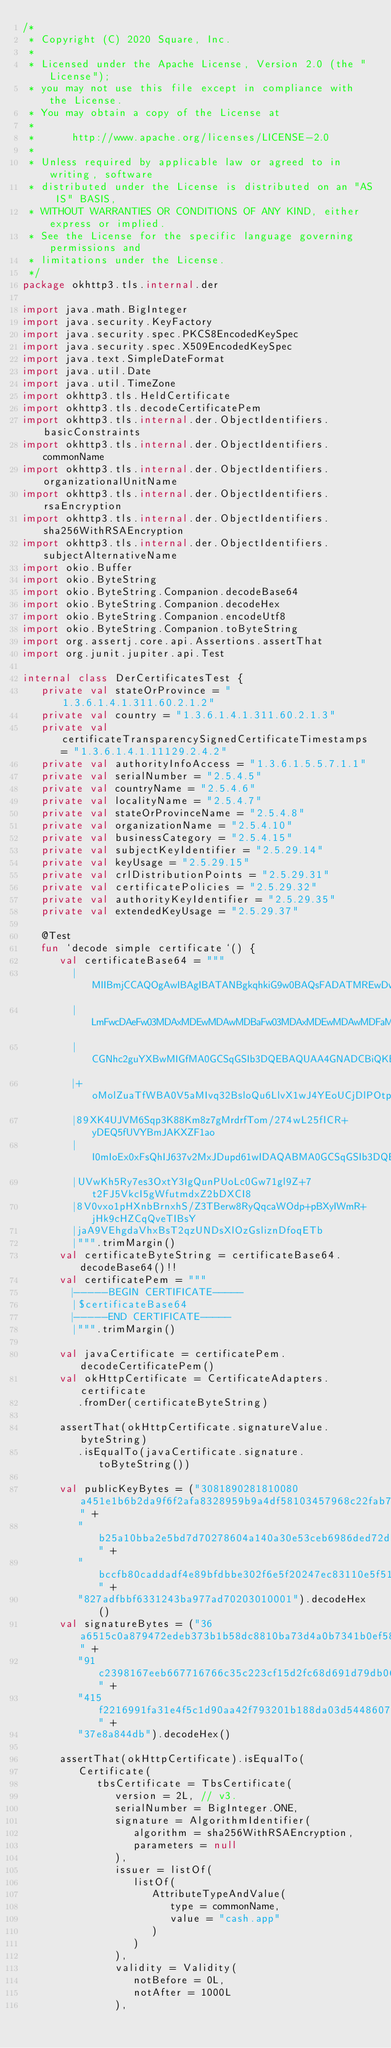Convert code to text. <code><loc_0><loc_0><loc_500><loc_500><_Kotlin_>/*
 * Copyright (C) 2020 Square, Inc.
 *
 * Licensed under the Apache License, Version 2.0 (the "License");
 * you may not use this file except in compliance with the License.
 * You may obtain a copy of the License at
 *
 *      http://www.apache.org/licenses/LICENSE-2.0
 *
 * Unless required by applicable law or agreed to in writing, software
 * distributed under the License is distributed on an "AS IS" BASIS,
 * WITHOUT WARRANTIES OR CONDITIONS OF ANY KIND, either express or implied.
 * See the License for the specific language governing permissions and
 * limitations under the License.
 */
package okhttp3.tls.internal.der

import java.math.BigInteger
import java.security.KeyFactory
import java.security.spec.PKCS8EncodedKeySpec
import java.security.spec.X509EncodedKeySpec
import java.text.SimpleDateFormat
import java.util.Date
import java.util.TimeZone
import okhttp3.tls.HeldCertificate
import okhttp3.tls.decodeCertificatePem
import okhttp3.tls.internal.der.ObjectIdentifiers.basicConstraints
import okhttp3.tls.internal.der.ObjectIdentifiers.commonName
import okhttp3.tls.internal.der.ObjectIdentifiers.organizationalUnitName
import okhttp3.tls.internal.der.ObjectIdentifiers.rsaEncryption
import okhttp3.tls.internal.der.ObjectIdentifiers.sha256WithRSAEncryption
import okhttp3.tls.internal.der.ObjectIdentifiers.subjectAlternativeName
import okio.Buffer
import okio.ByteString
import okio.ByteString.Companion.decodeBase64
import okio.ByteString.Companion.decodeHex
import okio.ByteString.Companion.encodeUtf8
import okio.ByteString.Companion.toByteString
import org.assertj.core.api.Assertions.assertThat
import org.junit.jupiter.api.Test

internal class DerCertificatesTest {
   private val stateOrProvince = "1.3.6.1.4.1.311.60.2.1.2"
   private val country = "1.3.6.1.4.1.311.60.2.1.3"
   private val certificateTransparencySignedCertificateTimestamps = "1.3.6.1.4.1.11129.2.4.2"
   private val authorityInfoAccess = "1.3.6.1.5.5.7.1.1"
   private val serialNumber = "2.5.4.5"
   private val countryName = "2.5.4.6"
   private val localityName = "2.5.4.7"
   private val stateOrProvinceName = "2.5.4.8"
   private val organizationName = "2.5.4.10"
   private val businessCategory = "2.5.4.15"
   private val subjectKeyIdentifier = "2.5.29.14"
   private val keyUsage = "2.5.29.15"
   private val crlDistributionPoints = "2.5.29.31"
   private val certificatePolicies = "2.5.29.32"
   private val authorityKeyIdentifier = "2.5.29.35"
   private val extendedKeyUsage = "2.5.29.37"

   @Test
   fun `decode simple certificate`() {
      val certificateBase64 = """
        |MIIBmjCCAQOgAwIBAgIBATANBgkqhkiG9w0BAQsFADATMREwDwYDVQQDEwhjYXNo
        |LmFwcDAeFw03MDAxMDEwMDAwMDBaFw03MDAxMDEwMDAwMDFaMBMxETAPBgNVBAMT
        |CGNhc2guYXBwMIGfMA0GCSqGSIb3DQEBAQUAA4GNADCBiQKBgQCApFHhtrLan28q
        |+oMolZuaTfWBA0V5aMIvq32BsloQu6LlvX1wJ4YEoUCjDlPOtpht7XLbUmBnbIzN
        |89XK4UJVM6Sqp3K88Km8z7gMrdrfTom/274wL25fICR+yDEQ5fUVYBmJAKXZF1ao
        |I0mIoEx0xFsQhIJ637v2MxJDupd61wIDAQABMA0GCSqGSIb3DQEBCwUAA4GBADam
        |UVwKh5Ry7es3OxtY3IgQunPUoLc0Gw71gl9Z+7t2FJ5VkcI5gWfutmdxZ2bDXCI8
        |8V0vxo1pHXnbBrnxhS/Z3TBerw8RyQqcaWOdp+pBXyIWmR+jHk9cHZCqQveTIBsY
        |jaA9VEhgdaVhxBsT2qzUNDsXlOzGsliznDfoqETb
        |""".trimMargin()
      val certificateByteString = certificateBase64.decodeBase64()!!
      val certificatePem = """
        |-----BEGIN CERTIFICATE-----
        |$certificateBase64
        |-----END CERTIFICATE-----
        |""".trimMargin()

      val javaCertificate = certificatePem.decodeCertificatePem()
      val okHttpCertificate = CertificateAdapters.certificate
         .fromDer(certificateByteString)

      assertThat(okHttpCertificate.signatureValue.byteString)
         .isEqualTo(javaCertificate.signature.toByteString())

      val publicKeyBytes = ("3081890281810080a451e1b6b2da9f6f2afa8328959b9a4df58103457968c22fab7d81" +
         "b25a10bba2e5bd7d70278604a140a30e53ceb6986ded72db5260676c8ccdf3d5cae1425533a4aaa772bcf0a9" +
         "bccfb80caddadf4e89bfdbbe302f6e5f20247ec83110e5f51560198900a5d91756a8234988a04c74c45b1084" +
         "827adfbbf6331243ba977ad70203010001").decodeHex()
      val signatureBytes = ("36a6515c0a879472edeb373b1b58dc8810ba73d4a0b7341b0ef5825f59fbbb76149e55" +
         "91c2398167eeb667716766c35c223cf15d2fc68d691d79db06b9f1852fd9dd305eaf0f11c90a9c69639da7ea" +
         "415f2216991fa31e4f5c1d90aa42f793201b188da03d54486075a561c41b13daacd4343b1794ecc6b258b39c" +
         "37e8a844db").decodeHex()

      assertThat(okHttpCertificate).isEqualTo(
         Certificate(
            tbsCertificate = TbsCertificate(
               version = 2L, // v3.
               serialNumber = BigInteger.ONE,
               signature = AlgorithmIdentifier(
                  algorithm = sha256WithRSAEncryption,
                  parameters = null
               ),
               issuer = listOf(
                  listOf(
                     AttributeTypeAndValue(
                        type = commonName,
                        value = "cash.app"
                     )
                  )
               ),
               validity = Validity(
                  notBefore = 0L,
                  notAfter = 1000L
               ),</code> 